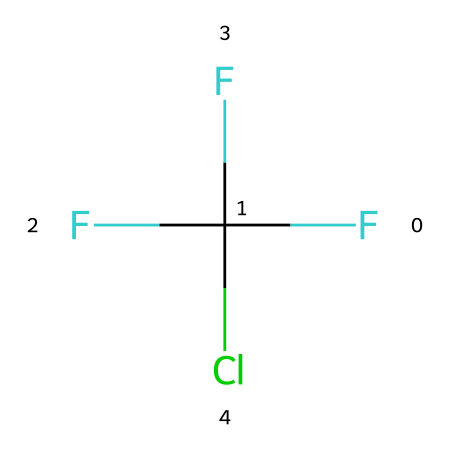What is the total number of carbon atoms in the chemical? The SMILES representation shows 'C' indicating carbon atoms. Counting the instances, there is one carbon atom present in the structure.
Answer: 1 How many fluorine atoms are present in the chemical structure? In the SMILES representation, 'F' is repeated three times, indicating three fluorine atoms attached to the carbon atom.
Answer: 3 What type of chemical is represented by this SMILES notation? The presence of halogens (fluorine and chlorine) bonded to carbon indicates that this compound is a chlorofluorocarbon, specifically a CFC.
Answer: chlorofluorocarbon What is the hybridization of the carbon atom in this chemical? The carbon atom is single bonded (in the context of the structure, it is surrounded by three fluorines and one chlorine) which indicates that it is tetrahedral, corresponding to sp3 hybridization.
Answer: sp3 Does this chemical contain any double bonds? The chemical structure represented by the SMILES notation includes only single bonds between the carbon, fluorine, and chlorine atoms, thus indicating the absence of double bonds.
Answer: no What would be the state of this chemical at room temperature? Given that chlorofluorocarbons are generally gases or volatile liquids at room temperature, this specific CFC would typically be expected to be gaseous under normal conditions.
Answer: gas How are chlorofluorocarbons classified in terms of environmental impact? Due to their role in ozone depletion, chlorofluorocarbons are classified as ozone-depleting substances, leading to their phase-out under international agreements like the Montreal Protocol.
Answer: ozone-depleting 